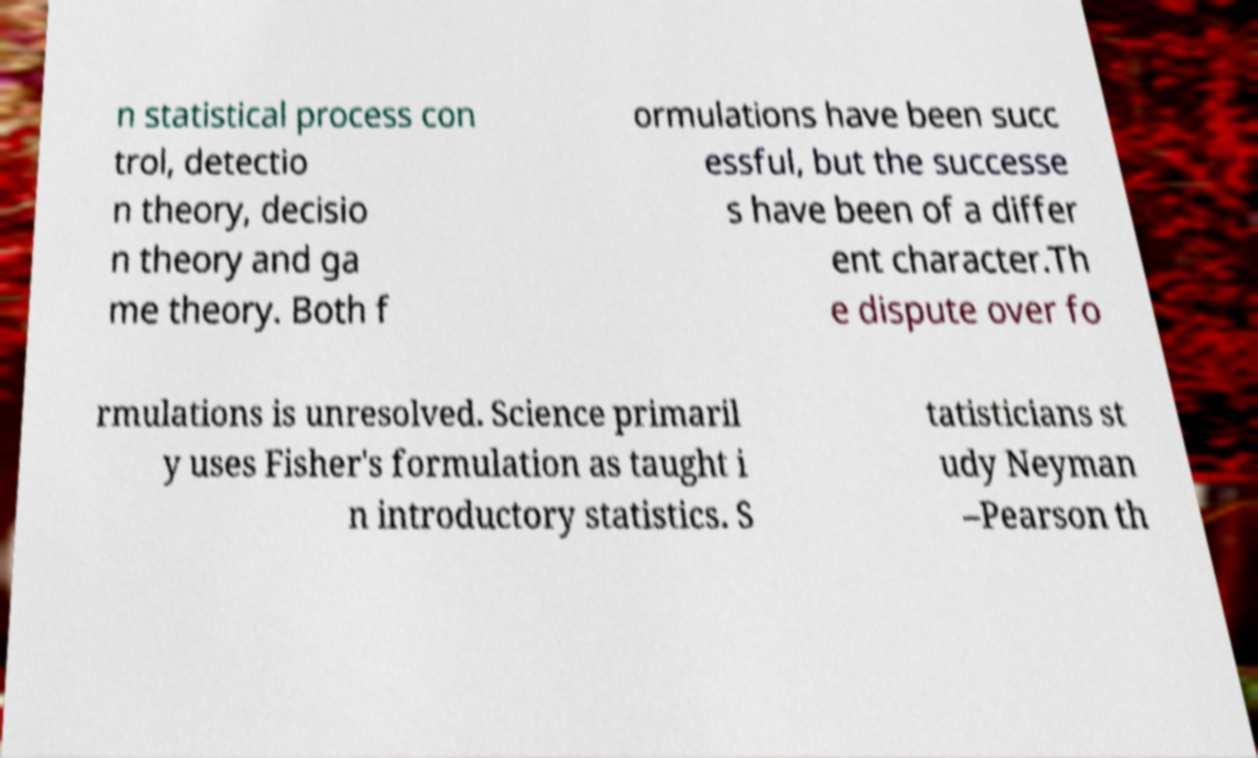Please read and relay the text visible in this image. What does it say? n statistical process con trol, detectio n theory, decisio n theory and ga me theory. Both f ormulations have been succ essful, but the successe s have been of a differ ent character.Th e dispute over fo rmulations is unresolved. Science primaril y uses Fisher's formulation as taught i n introductory statistics. S tatisticians st udy Neyman –Pearson th 